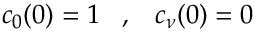Convert formula to latex. <formula><loc_0><loc_0><loc_500><loc_500>c _ { 0 } ( 0 ) = 1 \, , \, c _ { \nu } ( 0 ) = 0</formula> 